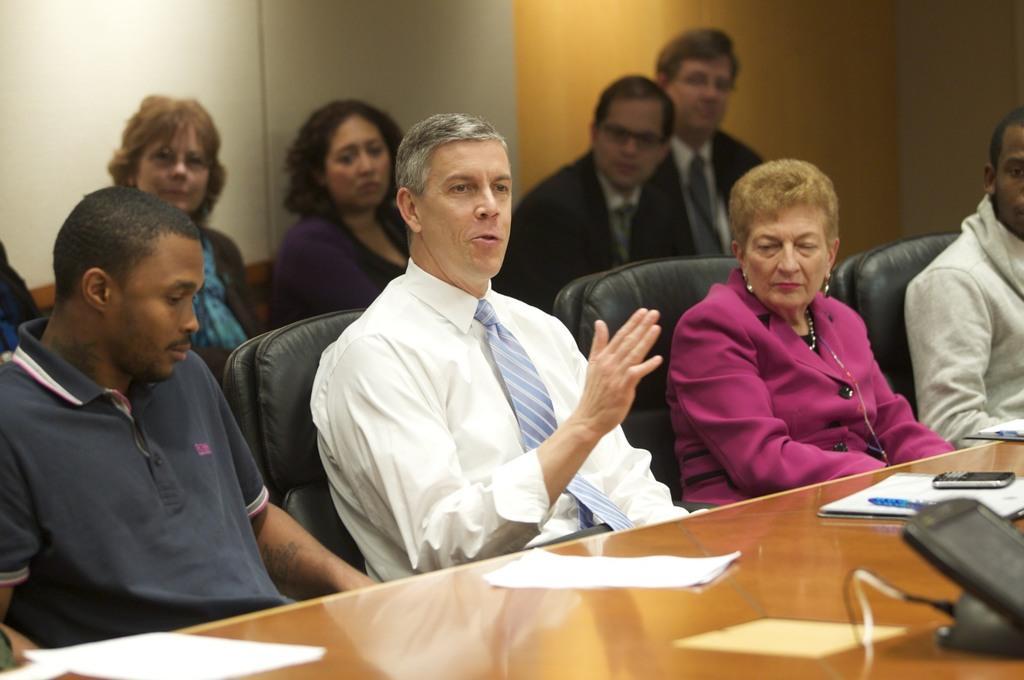Please provide a concise description of this image. This picture describes about group of people, they are seated on the chairs, in front of them we can find few papers, mobile and other things on the table. 